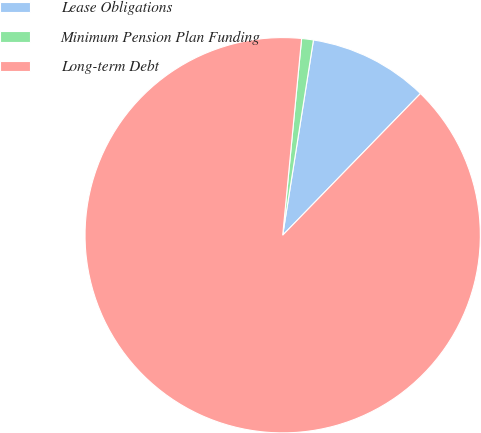Convert chart. <chart><loc_0><loc_0><loc_500><loc_500><pie_chart><fcel>Lease Obligations<fcel>Minimum Pension Plan Funding<fcel>Long-term Debt<nl><fcel>9.79%<fcel>0.96%<fcel>89.25%<nl></chart> 